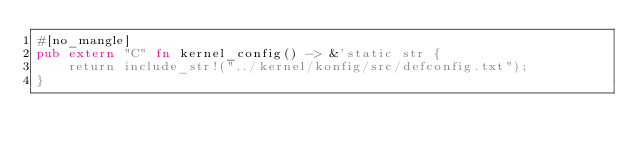<code> <loc_0><loc_0><loc_500><loc_500><_Rust_>#[no_mangle]
pub extern "C" fn kernel_config() -> &'static str {
    return include_str!("../kernel/konfig/src/defconfig.txt");
}
</code> 